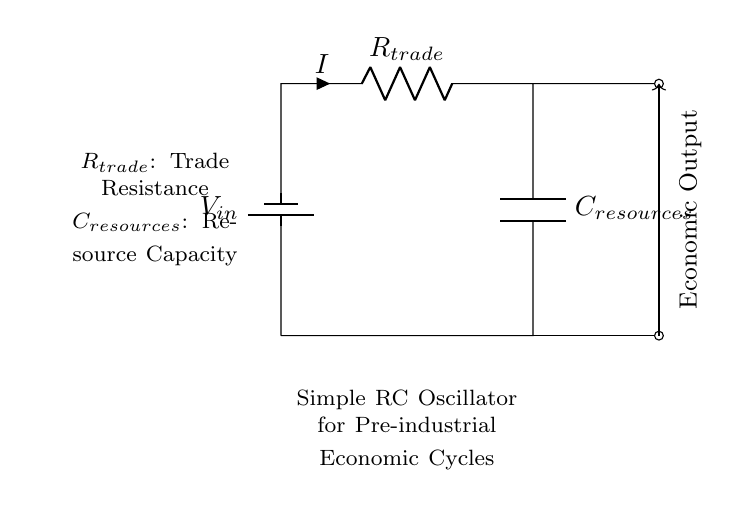What does the battery represent in this circuit? The battery represents the input voltage source for the oscillator, providing the necessary electrical energy to drive the circuit.
Answer: Input voltage What components are used in this oscillator? The components in this oscillator are a resistor and a capacitor, which together define the behavior of the circuit in generating oscillations.
Answer: Resistor and capacitor What does the notation R trade signify? R trade signifies the resistance related to the trade component in the economic model. It affects how readily resources are exchanged or utilized.
Answer: Trade resistance What is the role of the capacitor labeled C resources? The capacitor labeled C resources stores energy, representing the resource capacity in the economic cycles simulated by this oscillator.
Answer: Resource capacity How does this circuit simulate economic cycles? The RC oscillator creates periodic behavior, where the charge and discharge cycles of the capacitor represent fluctuations in resource availability, mimicking economic cycles.
Answer: By generating periodic oscillations What happens if R trade is increased? Increasing R trade will slow down the discharge rate of the capacitor, leading to longer time periods in the oscillation cycle, effectively simulating slower economic exchanges.
Answer: Slower oscillations 